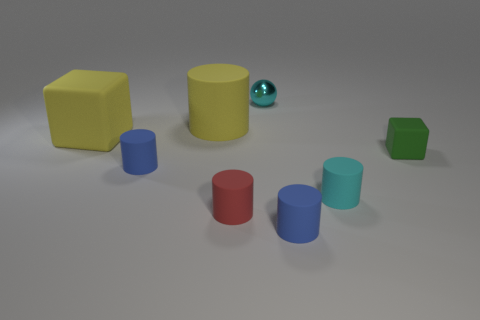Subtract 2 cylinders. How many cylinders are left? 3 Subtract all big yellow cylinders. How many cylinders are left? 4 Subtract all red cylinders. How many cylinders are left? 4 Subtract all gray cylinders. Subtract all blue blocks. How many cylinders are left? 5 Add 2 green blocks. How many objects exist? 10 Subtract all spheres. How many objects are left? 7 Subtract 0 blue spheres. How many objects are left? 8 Subtract all small purple rubber balls. Subtract all large yellow cubes. How many objects are left? 7 Add 3 big yellow things. How many big yellow things are left? 5 Add 1 small rubber cylinders. How many small rubber cylinders exist? 5 